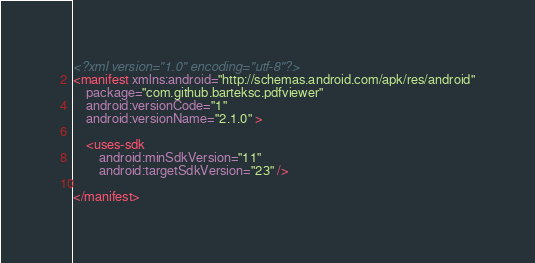<code> <loc_0><loc_0><loc_500><loc_500><_XML_><?xml version="1.0" encoding="utf-8"?>
<manifest xmlns:android="http://schemas.android.com/apk/res/android"
    package="com.github.barteksc.pdfviewer"
    android:versionCode="1"
    android:versionName="2.1.0" >

    <uses-sdk
        android:minSdkVersion="11"
        android:targetSdkVersion="23" />

</manifest></code> 